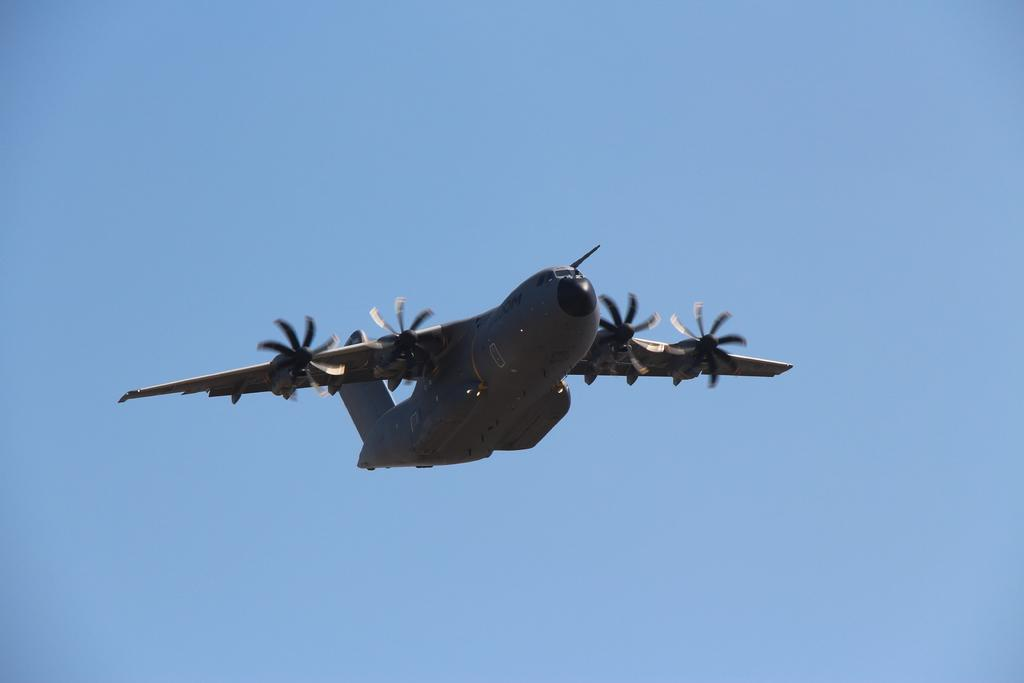What is the main subject of the image? The main subject of the image is an aeroplane. Where is the aeroplane located in the image? The aeroplane is in the middle of the image. What color is the aeroplane? The aeroplane is grey in color. What can be seen in the background of the image? There is a blue sky in the background of the image. Can you tell me how many gravestones are present in the image? There are no gravestones or cemeteries present in the image; it features an aeroplane. What type of education is being offered in the image? There is no educational content or institution present in the image; it features an aeroplane. 